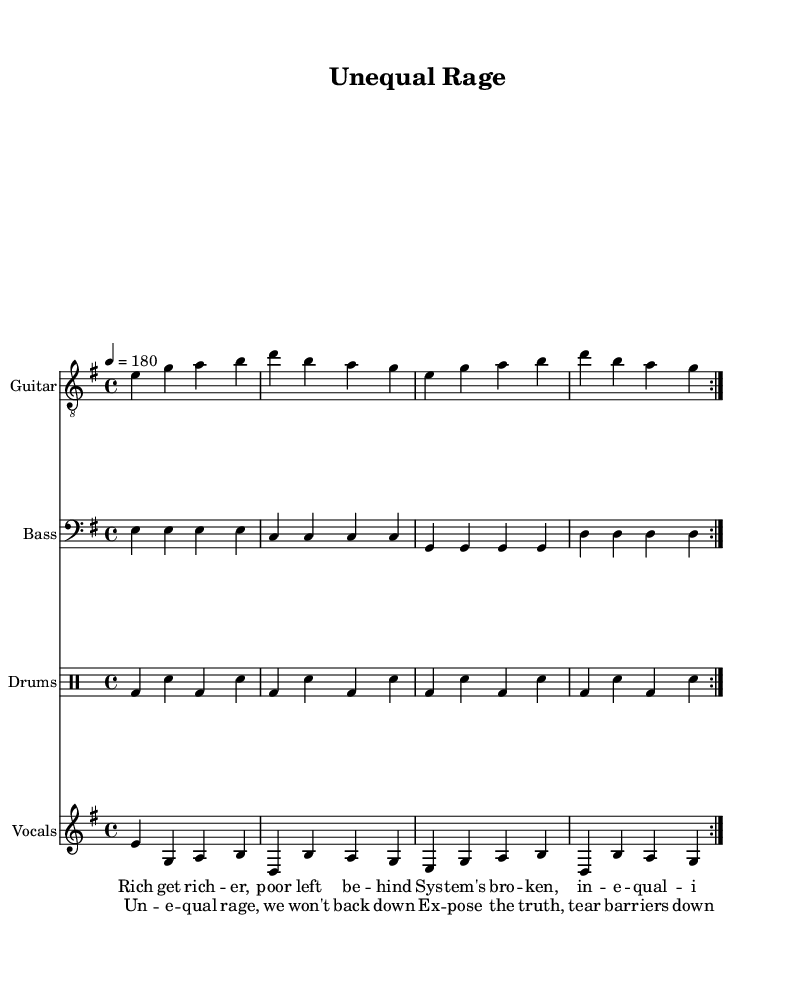What is the key signature of this music? The key signature is indicated by the sharp or flat symbols at the beginning of the staff. In this case, it is 'e minor', which has one sharp (F#).
Answer: E minor What is the time signature of this music? The time signature appears at the beginning of the music and indicates how many beats are in each measure. Here, it is marked as 4/4, meaning there are four beats per measure.
Answer: 4/4 What is the tempo of this piece? The tempo is indicated above the staff and shows the speed of the music. In this case, it is marked as 4 = 180, which means there are 180 beats per minute.
Answer: 180 How many times does the verse repeat? The repeat signs (indicated by the volta) show that the verse should be played twice before moving on. This is confirmed by the symbol indicating a repeat for the section.
Answer: Two What instruments are used in this piece? The instruments are labeled alongside their respective staves at the beginning of the sheet. There are three instruments: Guitar, Bass, and Drums.
Answer: Guitar, Bass, Drums What lyrical theme is expressed in the chorus? The theme can be deduced by analyzing the lyrics provided. The chorus expresses a desire for social change and justice, emphasizing themes of resistance and empowerment.
Answer: Social change 